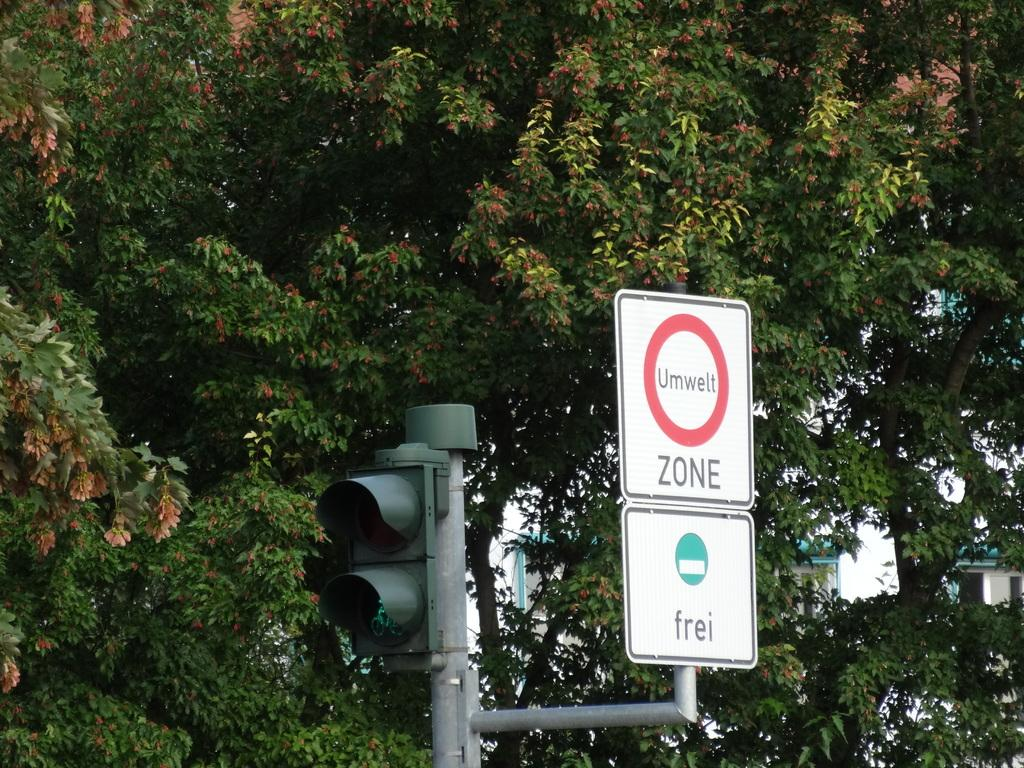What is the main object in the image? There is a traffic signal in the image. What else is attached to the traffic pole? There are signage boards attached to the traffic pole. What can be seen in the background of the image? There are trees and a house in the background of the image. What is the name of the person standing next to the mailbox in the image? There is no mailbox or person present in the image. What type of station is visible in the background of the image? There is no station visible in the background of the image. 